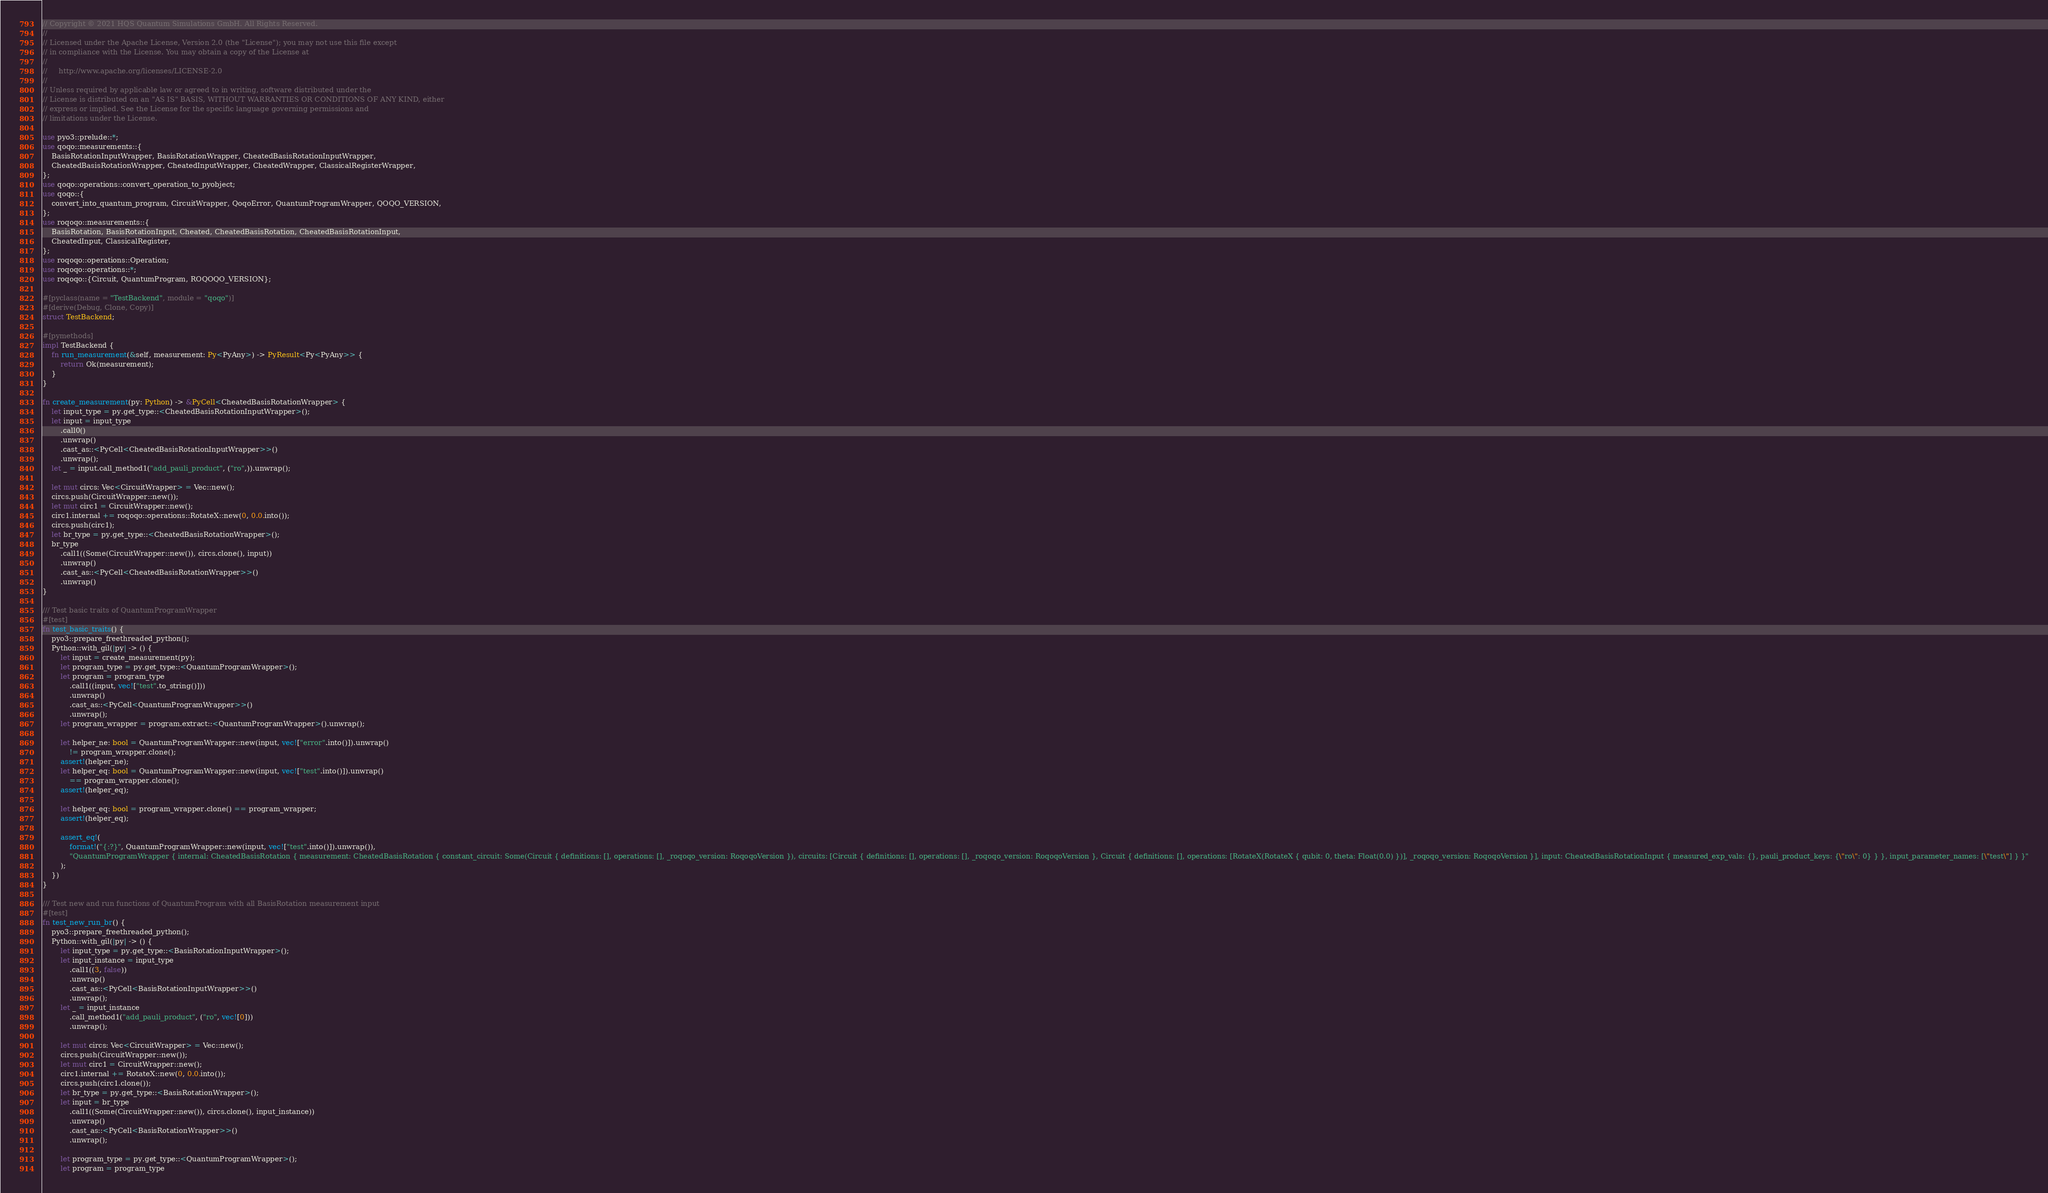<code> <loc_0><loc_0><loc_500><loc_500><_Rust_>// Copyright © 2021 HQS Quantum Simulations GmbH. All Rights Reserved.
//
// Licensed under the Apache License, Version 2.0 (the "License"); you may not use this file except
// in compliance with the License. You may obtain a copy of the License at
//
//     http://www.apache.org/licenses/LICENSE-2.0
//
// Unless required by applicable law or agreed to in writing, software distributed under the
// License is distributed on an "AS IS" BASIS, WITHOUT WARRANTIES OR CONDITIONS OF ANY KIND, either
// express or implied. See the License for the specific language governing permissions and
// limitations under the License.

use pyo3::prelude::*;
use qoqo::measurements::{
    BasisRotationInputWrapper, BasisRotationWrapper, CheatedBasisRotationInputWrapper,
    CheatedBasisRotationWrapper, CheatedInputWrapper, CheatedWrapper, ClassicalRegisterWrapper,
};
use qoqo::operations::convert_operation_to_pyobject;
use qoqo::{
    convert_into_quantum_program, CircuitWrapper, QoqoError, QuantumProgramWrapper, QOQO_VERSION,
};
use roqoqo::measurements::{
    BasisRotation, BasisRotationInput, Cheated, CheatedBasisRotation, CheatedBasisRotationInput,
    CheatedInput, ClassicalRegister,
};
use roqoqo::operations::Operation;
use roqoqo::operations::*;
use roqoqo::{Circuit, QuantumProgram, ROQOQO_VERSION};

#[pyclass(name = "TestBackend", module = "qoqo")]
#[derive(Debug, Clone, Copy)]
struct TestBackend;

#[pymethods]
impl TestBackend {
    fn run_measurement(&self, measurement: Py<PyAny>) -> PyResult<Py<PyAny>> {
        return Ok(measurement);
    }
}

fn create_measurement(py: Python) -> &PyCell<CheatedBasisRotationWrapper> {
    let input_type = py.get_type::<CheatedBasisRotationInputWrapper>();
    let input = input_type
        .call0()
        .unwrap()
        .cast_as::<PyCell<CheatedBasisRotationInputWrapper>>()
        .unwrap();
    let _ = input.call_method1("add_pauli_product", ("ro",)).unwrap();

    let mut circs: Vec<CircuitWrapper> = Vec::new();
    circs.push(CircuitWrapper::new());
    let mut circ1 = CircuitWrapper::new();
    circ1.internal += roqoqo::operations::RotateX::new(0, 0.0.into());
    circs.push(circ1);
    let br_type = py.get_type::<CheatedBasisRotationWrapper>();
    br_type
        .call1((Some(CircuitWrapper::new()), circs.clone(), input))
        .unwrap()
        .cast_as::<PyCell<CheatedBasisRotationWrapper>>()
        .unwrap()
}

/// Test basic traits of QuantumProgramWrapper
#[test]
fn test_basic_traits() {
    pyo3::prepare_freethreaded_python();
    Python::with_gil(|py| -> () {
        let input = create_measurement(py);
        let program_type = py.get_type::<QuantumProgramWrapper>();
        let program = program_type
            .call1((input, vec!["test".to_string()]))
            .unwrap()
            .cast_as::<PyCell<QuantumProgramWrapper>>()
            .unwrap();
        let program_wrapper = program.extract::<QuantumProgramWrapper>().unwrap();

        let helper_ne: bool = QuantumProgramWrapper::new(input, vec!["error".into()]).unwrap()
            != program_wrapper.clone();
        assert!(helper_ne);
        let helper_eq: bool = QuantumProgramWrapper::new(input, vec!["test".into()]).unwrap()
            == program_wrapper.clone();
        assert!(helper_eq);

        let helper_eq: bool = program_wrapper.clone() == program_wrapper;
        assert!(helper_eq);

        assert_eq!(
            format!("{:?}", QuantumProgramWrapper::new(input, vec!["test".into()]).unwrap()),
            "QuantumProgramWrapper { internal: CheatedBasisRotation { measurement: CheatedBasisRotation { constant_circuit: Some(Circuit { definitions: [], operations: [], _roqoqo_version: RoqoqoVersion }), circuits: [Circuit { definitions: [], operations: [], _roqoqo_version: RoqoqoVersion }, Circuit { definitions: [], operations: [RotateX(RotateX { qubit: 0, theta: Float(0.0) })], _roqoqo_version: RoqoqoVersion }], input: CheatedBasisRotationInput { measured_exp_vals: {}, pauli_product_keys: {\"ro\": 0} } }, input_parameter_names: [\"test\"] } }"
        );
    })
}

/// Test new and run functions of QuantumProgram with all BasisRotation measurement input
#[test]
fn test_new_run_br() {
    pyo3::prepare_freethreaded_python();
    Python::with_gil(|py| -> () {
        let input_type = py.get_type::<BasisRotationInputWrapper>();
        let input_instance = input_type
            .call1((3, false))
            .unwrap()
            .cast_as::<PyCell<BasisRotationInputWrapper>>()
            .unwrap();
        let _ = input_instance
            .call_method1("add_pauli_product", ("ro", vec![0]))
            .unwrap();

        let mut circs: Vec<CircuitWrapper> = Vec::new();
        circs.push(CircuitWrapper::new());
        let mut circ1 = CircuitWrapper::new();
        circ1.internal += RotateX::new(0, 0.0.into());
        circs.push(circ1.clone());
        let br_type = py.get_type::<BasisRotationWrapper>();
        let input = br_type
            .call1((Some(CircuitWrapper::new()), circs.clone(), input_instance))
            .unwrap()
            .cast_as::<PyCell<BasisRotationWrapper>>()
            .unwrap();

        let program_type = py.get_type::<QuantumProgramWrapper>();
        let program = program_type</code> 